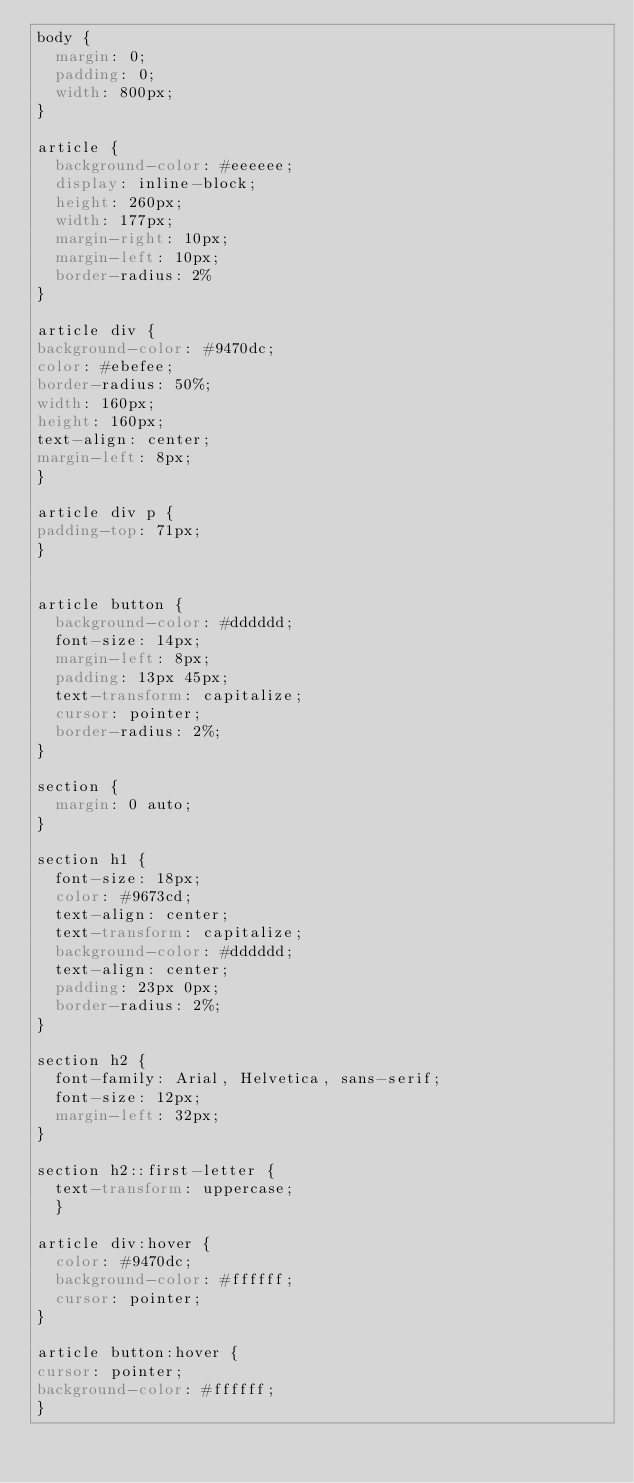<code> <loc_0><loc_0><loc_500><loc_500><_CSS_>body { 
	margin: 0;
	padding: 0;
	width: 800px;
}

article { 
	background-color: #eeeeee;
	display: inline-block;
	height: 260px; 
	width: 177px;
	margin-right: 10px;
	margin-left: 10px;
	border-radius: 2%
}

article div {
background-color: #9470dc;
color: #ebefee;
border-radius: 50%;
width: 160px;
height: 160px;
text-align: center;
margin-left: 8px;
}

article div p { 
padding-top: 71px;
}


article button { 
	background-color: #dddddd;
	font-size: 14px;
	margin-left: 8px;
	padding: 13px 45px;
	text-transform: capitalize;
	cursor: pointer;
	border-radius: 2%;
}

section { 
	margin: 0 auto;
}

section h1 { 
	font-size: 18px;
	color: #9673cd;
	text-align: center;
	text-transform: capitalize;
	background-color: #dddddd;
	text-align: center;
	padding: 23px 0px;
	border-radius: 2%;
}

section h2 { 
	font-family: Arial, Helvetica, sans-serif;
	font-size: 12px;
	margin-left: 32px;
}

section h2::first-letter { 
	text-transform: uppercase;
	}

article div:hover { 
	color: #9470dc;
	background-color: #ffffff;
	cursor: pointer;
}

article button:hover {
cursor: pointer;
background-color: #ffffff; 
}
</code> 